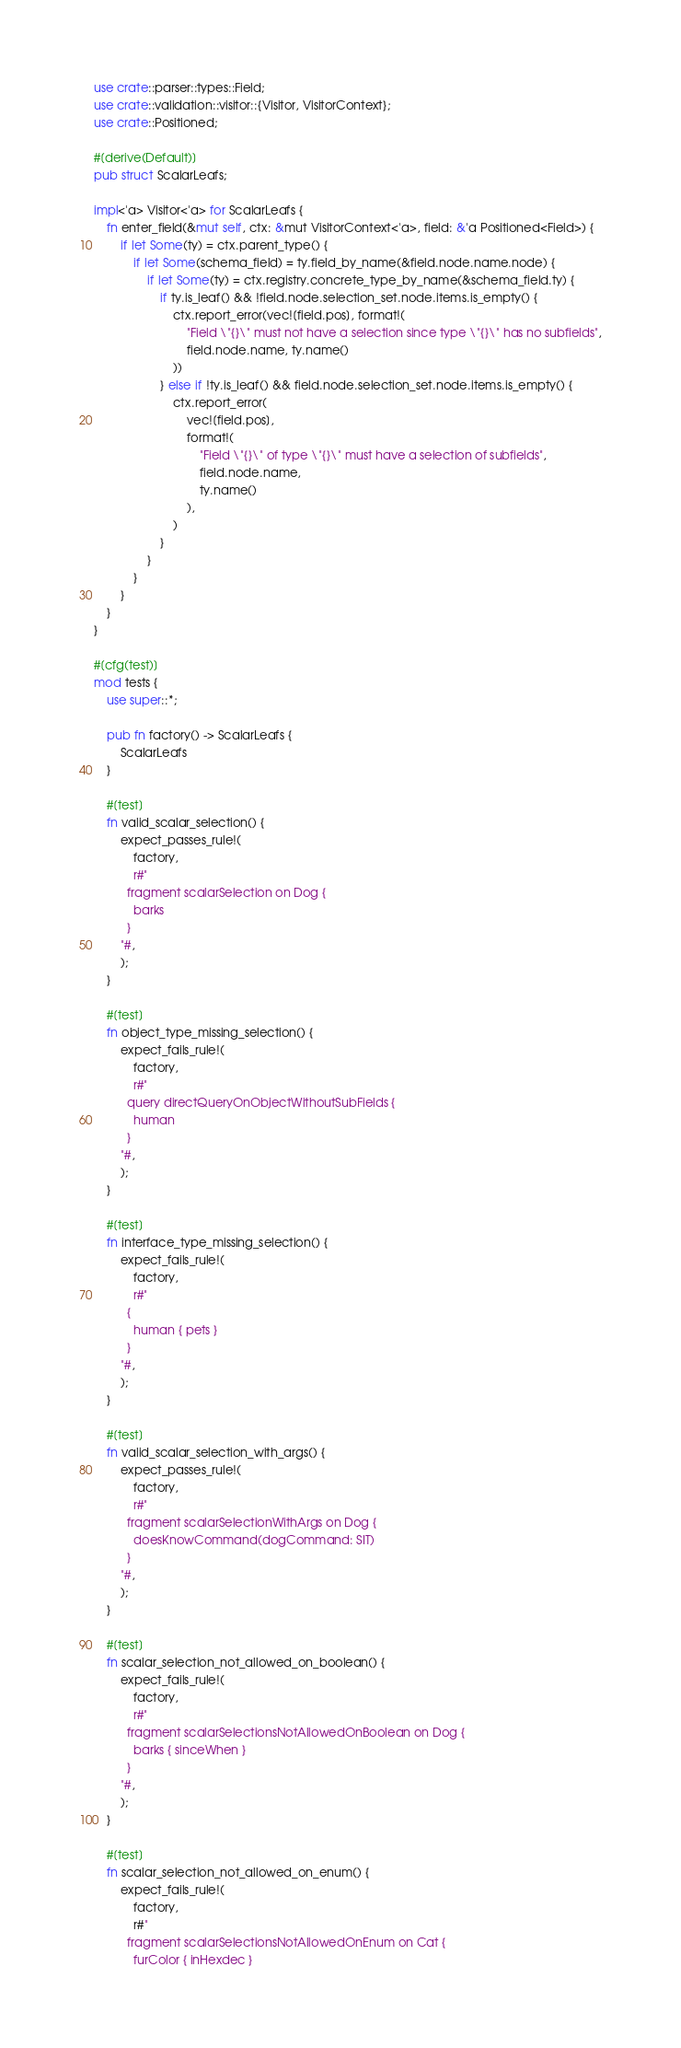<code> <loc_0><loc_0><loc_500><loc_500><_Rust_>use crate::parser::types::Field;
use crate::validation::visitor::{Visitor, VisitorContext};
use crate::Positioned;

#[derive(Default)]
pub struct ScalarLeafs;

impl<'a> Visitor<'a> for ScalarLeafs {
    fn enter_field(&mut self, ctx: &mut VisitorContext<'a>, field: &'a Positioned<Field>) {
        if let Some(ty) = ctx.parent_type() {
            if let Some(schema_field) = ty.field_by_name(&field.node.name.node) {
                if let Some(ty) = ctx.registry.concrete_type_by_name(&schema_field.ty) {
                    if ty.is_leaf() && !field.node.selection_set.node.items.is_empty() {
                        ctx.report_error(vec![field.pos], format!(
                            "Field \"{}\" must not have a selection since type \"{}\" has no subfields",
                            field.node.name, ty.name()
                        ))
                    } else if !ty.is_leaf() && field.node.selection_set.node.items.is_empty() {
                        ctx.report_error(
                            vec![field.pos],
                            format!(
                                "Field \"{}\" of type \"{}\" must have a selection of subfields",
                                field.node.name,
                                ty.name()
                            ),
                        )
                    }
                }
            }
        }
    }
}

#[cfg(test)]
mod tests {
    use super::*;

    pub fn factory() -> ScalarLeafs {
        ScalarLeafs
    }

    #[test]
    fn valid_scalar_selection() {
        expect_passes_rule!(
            factory,
            r#"
          fragment scalarSelection on Dog {
            barks
          }
        "#,
        );
    }

    #[test]
    fn object_type_missing_selection() {
        expect_fails_rule!(
            factory,
            r#"
          query directQueryOnObjectWithoutSubFields {
            human
          }
        "#,
        );
    }

    #[test]
    fn interface_type_missing_selection() {
        expect_fails_rule!(
            factory,
            r#"
          {
            human { pets }
          }
        "#,
        );
    }

    #[test]
    fn valid_scalar_selection_with_args() {
        expect_passes_rule!(
            factory,
            r#"
          fragment scalarSelectionWithArgs on Dog {
            doesKnowCommand(dogCommand: SIT)
          }
        "#,
        );
    }

    #[test]
    fn scalar_selection_not_allowed_on_boolean() {
        expect_fails_rule!(
            factory,
            r#"
          fragment scalarSelectionsNotAllowedOnBoolean on Dog {
            barks { sinceWhen }
          }
        "#,
        );
    }

    #[test]
    fn scalar_selection_not_allowed_on_enum() {
        expect_fails_rule!(
            factory,
            r#"
          fragment scalarSelectionsNotAllowedOnEnum on Cat {
            furColor { inHexdec }</code> 